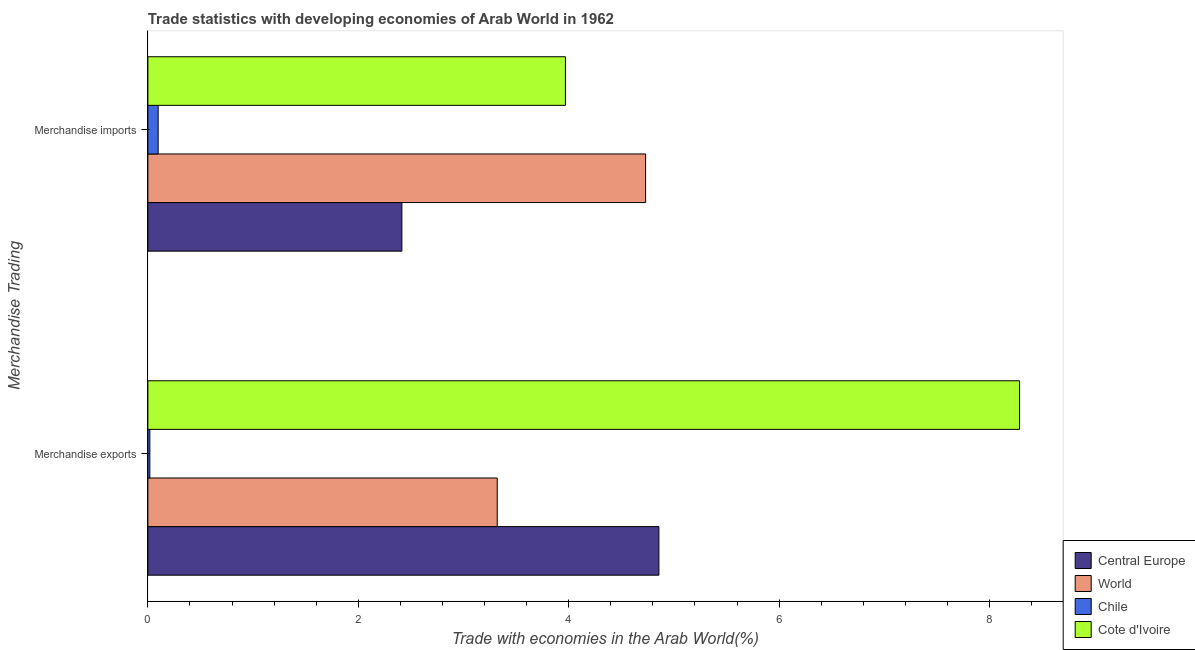How many groups of bars are there?
Offer a terse response. 2. Are the number of bars per tick equal to the number of legend labels?
Offer a very short reply. Yes. Are the number of bars on each tick of the Y-axis equal?
Give a very brief answer. Yes. How many bars are there on the 2nd tick from the top?
Offer a very short reply. 4. How many bars are there on the 2nd tick from the bottom?
Your answer should be compact. 4. What is the label of the 2nd group of bars from the top?
Offer a terse response. Merchandise exports. What is the merchandise exports in World?
Provide a short and direct response. 3.32. Across all countries, what is the maximum merchandise exports?
Keep it short and to the point. 8.29. Across all countries, what is the minimum merchandise imports?
Your answer should be compact. 0.1. In which country was the merchandise imports maximum?
Make the answer very short. World. What is the total merchandise exports in the graph?
Your response must be concise. 16.48. What is the difference between the merchandise imports in Chile and that in World?
Ensure brevity in your answer.  -4.63. What is the difference between the merchandise imports in World and the merchandise exports in Cote d'Ivoire?
Offer a terse response. -3.55. What is the average merchandise exports per country?
Give a very brief answer. 4.12. What is the difference between the merchandise imports and merchandise exports in Central Europe?
Your answer should be very brief. -2.44. In how many countries, is the merchandise exports greater than 3.2 %?
Provide a succinct answer. 3. What is the ratio of the merchandise exports in Central Europe to that in World?
Give a very brief answer. 1.46. Is the merchandise imports in Cote d'Ivoire less than that in World?
Give a very brief answer. Yes. What does the 4th bar from the top in Merchandise exports represents?
Your response must be concise. Central Europe. What does the 1st bar from the bottom in Merchandise imports represents?
Offer a terse response. Central Europe. How many bars are there?
Your answer should be compact. 8. Are all the bars in the graph horizontal?
Offer a very short reply. Yes. How many countries are there in the graph?
Offer a very short reply. 4. What is the difference between two consecutive major ticks on the X-axis?
Your answer should be compact. 2. Are the values on the major ticks of X-axis written in scientific E-notation?
Provide a succinct answer. No. Does the graph contain any zero values?
Give a very brief answer. No. Where does the legend appear in the graph?
Provide a succinct answer. Bottom right. How many legend labels are there?
Give a very brief answer. 4. How are the legend labels stacked?
Your answer should be compact. Vertical. What is the title of the graph?
Keep it short and to the point. Trade statistics with developing economies of Arab World in 1962. What is the label or title of the X-axis?
Keep it short and to the point. Trade with economies in the Arab World(%). What is the label or title of the Y-axis?
Provide a short and direct response. Merchandise Trading. What is the Trade with economies in the Arab World(%) in Central Europe in Merchandise exports?
Offer a terse response. 4.86. What is the Trade with economies in the Arab World(%) of World in Merchandise exports?
Provide a short and direct response. 3.32. What is the Trade with economies in the Arab World(%) in Chile in Merchandise exports?
Give a very brief answer. 0.02. What is the Trade with economies in the Arab World(%) of Cote d'Ivoire in Merchandise exports?
Give a very brief answer. 8.29. What is the Trade with economies in the Arab World(%) in Central Europe in Merchandise imports?
Provide a short and direct response. 2.41. What is the Trade with economies in the Arab World(%) in World in Merchandise imports?
Keep it short and to the point. 4.73. What is the Trade with economies in the Arab World(%) in Chile in Merchandise imports?
Your response must be concise. 0.1. What is the Trade with economies in the Arab World(%) in Cote d'Ivoire in Merchandise imports?
Your response must be concise. 3.97. Across all Merchandise Trading, what is the maximum Trade with economies in the Arab World(%) in Central Europe?
Give a very brief answer. 4.86. Across all Merchandise Trading, what is the maximum Trade with economies in the Arab World(%) in World?
Ensure brevity in your answer.  4.73. Across all Merchandise Trading, what is the maximum Trade with economies in the Arab World(%) of Chile?
Keep it short and to the point. 0.1. Across all Merchandise Trading, what is the maximum Trade with economies in the Arab World(%) of Cote d'Ivoire?
Keep it short and to the point. 8.29. Across all Merchandise Trading, what is the minimum Trade with economies in the Arab World(%) in Central Europe?
Make the answer very short. 2.41. Across all Merchandise Trading, what is the minimum Trade with economies in the Arab World(%) of World?
Provide a succinct answer. 3.32. Across all Merchandise Trading, what is the minimum Trade with economies in the Arab World(%) of Chile?
Ensure brevity in your answer.  0.02. Across all Merchandise Trading, what is the minimum Trade with economies in the Arab World(%) of Cote d'Ivoire?
Your response must be concise. 3.97. What is the total Trade with economies in the Arab World(%) in Central Europe in the graph?
Keep it short and to the point. 7.27. What is the total Trade with economies in the Arab World(%) of World in the graph?
Give a very brief answer. 8.05. What is the total Trade with economies in the Arab World(%) of Chile in the graph?
Keep it short and to the point. 0.12. What is the total Trade with economies in the Arab World(%) of Cote d'Ivoire in the graph?
Ensure brevity in your answer.  12.26. What is the difference between the Trade with economies in the Arab World(%) in Central Europe in Merchandise exports and that in Merchandise imports?
Offer a very short reply. 2.44. What is the difference between the Trade with economies in the Arab World(%) in World in Merchandise exports and that in Merchandise imports?
Ensure brevity in your answer.  -1.41. What is the difference between the Trade with economies in the Arab World(%) of Chile in Merchandise exports and that in Merchandise imports?
Give a very brief answer. -0.08. What is the difference between the Trade with economies in the Arab World(%) in Cote d'Ivoire in Merchandise exports and that in Merchandise imports?
Ensure brevity in your answer.  4.32. What is the difference between the Trade with economies in the Arab World(%) of Central Europe in Merchandise exports and the Trade with economies in the Arab World(%) of World in Merchandise imports?
Make the answer very short. 0.13. What is the difference between the Trade with economies in the Arab World(%) in Central Europe in Merchandise exports and the Trade with economies in the Arab World(%) in Chile in Merchandise imports?
Make the answer very short. 4.76. What is the difference between the Trade with economies in the Arab World(%) in Central Europe in Merchandise exports and the Trade with economies in the Arab World(%) in Cote d'Ivoire in Merchandise imports?
Your answer should be very brief. 0.89. What is the difference between the Trade with economies in the Arab World(%) in World in Merchandise exports and the Trade with economies in the Arab World(%) in Chile in Merchandise imports?
Your response must be concise. 3.22. What is the difference between the Trade with economies in the Arab World(%) in World in Merchandise exports and the Trade with economies in the Arab World(%) in Cote d'Ivoire in Merchandise imports?
Provide a short and direct response. -0.65. What is the difference between the Trade with economies in the Arab World(%) in Chile in Merchandise exports and the Trade with economies in the Arab World(%) in Cote d'Ivoire in Merchandise imports?
Your answer should be compact. -3.95. What is the average Trade with economies in the Arab World(%) in Central Europe per Merchandise Trading?
Keep it short and to the point. 3.64. What is the average Trade with economies in the Arab World(%) in World per Merchandise Trading?
Provide a succinct answer. 4.03. What is the average Trade with economies in the Arab World(%) in Chile per Merchandise Trading?
Make the answer very short. 0.06. What is the average Trade with economies in the Arab World(%) in Cote d'Ivoire per Merchandise Trading?
Your response must be concise. 6.13. What is the difference between the Trade with economies in the Arab World(%) in Central Europe and Trade with economies in the Arab World(%) in World in Merchandise exports?
Ensure brevity in your answer.  1.54. What is the difference between the Trade with economies in the Arab World(%) in Central Europe and Trade with economies in the Arab World(%) in Chile in Merchandise exports?
Give a very brief answer. 4.84. What is the difference between the Trade with economies in the Arab World(%) of Central Europe and Trade with economies in the Arab World(%) of Cote d'Ivoire in Merchandise exports?
Offer a very short reply. -3.43. What is the difference between the Trade with economies in the Arab World(%) in World and Trade with economies in the Arab World(%) in Chile in Merchandise exports?
Your answer should be very brief. 3.3. What is the difference between the Trade with economies in the Arab World(%) in World and Trade with economies in the Arab World(%) in Cote d'Ivoire in Merchandise exports?
Keep it short and to the point. -4.97. What is the difference between the Trade with economies in the Arab World(%) in Chile and Trade with economies in the Arab World(%) in Cote d'Ivoire in Merchandise exports?
Offer a terse response. -8.27. What is the difference between the Trade with economies in the Arab World(%) of Central Europe and Trade with economies in the Arab World(%) of World in Merchandise imports?
Keep it short and to the point. -2.32. What is the difference between the Trade with economies in the Arab World(%) of Central Europe and Trade with economies in the Arab World(%) of Chile in Merchandise imports?
Make the answer very short. 2.32. What is the difference between the Trade with economies in the Arab World(%) in Central Europe and Trade with economies in the Arab World(%) in Cote d'Ivoire in Merchandise imports?
Keep it short and to the point. -1.55. What is the difference between the Trade with economies in the Arab World(%) in World and Trade with economies in the Arab World(%) in Chile in Merchandise imports?
Make the answer very short. 4.63. What is the difference between the Trade with economies in the Arab World(%) in World and Trade with economies in the Arab World(%) in Cote d'Ivoire in Merchandise imports?
Offer a terse response. 0.76. What is the difference between the Trade with economies in the Arab World(%) of Chile and Trade with economies in the Arab World(%) of Cote d'Ivoire in Merchandise imports?
Make the answer very short. -3.87. What is the ratio of the Trade with economies in the Arab World(%) in Central Europe in Merchandise exports to that in Merchandise imports?
Ensure brevity in your answer.  2.01. What is the ratio of the Trade with economies in the Arab World(%) in World in Merchandise exports to that in Merchandise imports?
Your answer should be compact. 0.7. What is the ratio of the Trade with economies in the Arab World(%) of Chile in Merchandise exports to that in Merchandise imports?
Make the answer very short. 0.19. What is the ratio of the Trade with economies in the Arab World(%) of Cote d'Ivoire in Merchandise exports to that in Merchandise imports?
Keep it short and to the point. 2.09. What is the difference between the highest and the second highest Trade with economies in the Arab World(%) of Central Europe?
Ensure brevity in your answer.  2.44. What is the difference between the highest and the second highest Trade with economies in the Arab World(%) in World?
Keep it short and to the point. 1.41. What is the difference between the highest and the second highest Trade with economies in the Arab World(%) in Chile?
Ensure brevity in your answer.  0.08. What is the difference between the highest and the second highest Trade with economies in the Arab World(%) of Cote d'Ivoire?
Make the answer very short. 4.32. What is the difference between the highest and the lowest Trade with economies in the Arab World(%) in Central Europe?
Your answer should be very brief. 2.44. What is the difference between the highest and the lowest Trade with economies in the Arab World(%) in World?
Provide a succinct answer. 1.41. What is the difference between the highest and the lowest Trade with economies in the Arab World(%) in Chile?
Offer a very short reply. 0.08. What is the difference between the highest and the lowest Trade with economies in the Arab World(%) of Cote d'Ivoire?
Your answer should be compact. 4.32. 